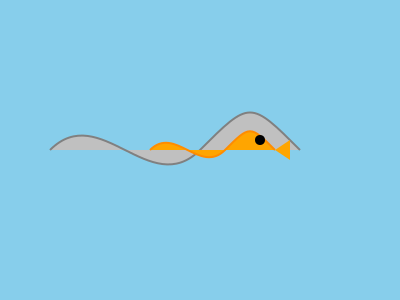In the underwater image above, which feature is most indicative that this fish belongs to the family Carangidae (jacks and pompanos)? To identify the fish family from the underwater imagery, we need to analyze key morphological features:

1. Body shape: The fish has a laterally compressed, oval-shaped body, which is common in many reef fish families.

2. Fin structure: The fish appears to have a continuous dorsal fin, which is characteristic of many fish families.

3. Tail shape: The tail is not clearly visible in this simplified image.

4. Distinctive features: The most notable feature is the presence of a dark spot near the operculum (gill cover) and a slightly pronounced forehead.

5. Family-specific traits: Carangidae family members often have a distinctive dark spot on the operculum and a slightly pronounced forehead, which are both visible in this image.

6. Color: While color can be variable, the golden-orange color is consistent with many jack species.

The combination of the body shape, the dark spot near the operculum, and the slightly pronounced forehead are strong indicators that this fish belongs to the Carangidae family. The most distinctive and reliable feature for this identification is the dark spot near the operculum, which is a key characteristic of many jack species.
Answer: Dark spot near the operculum 